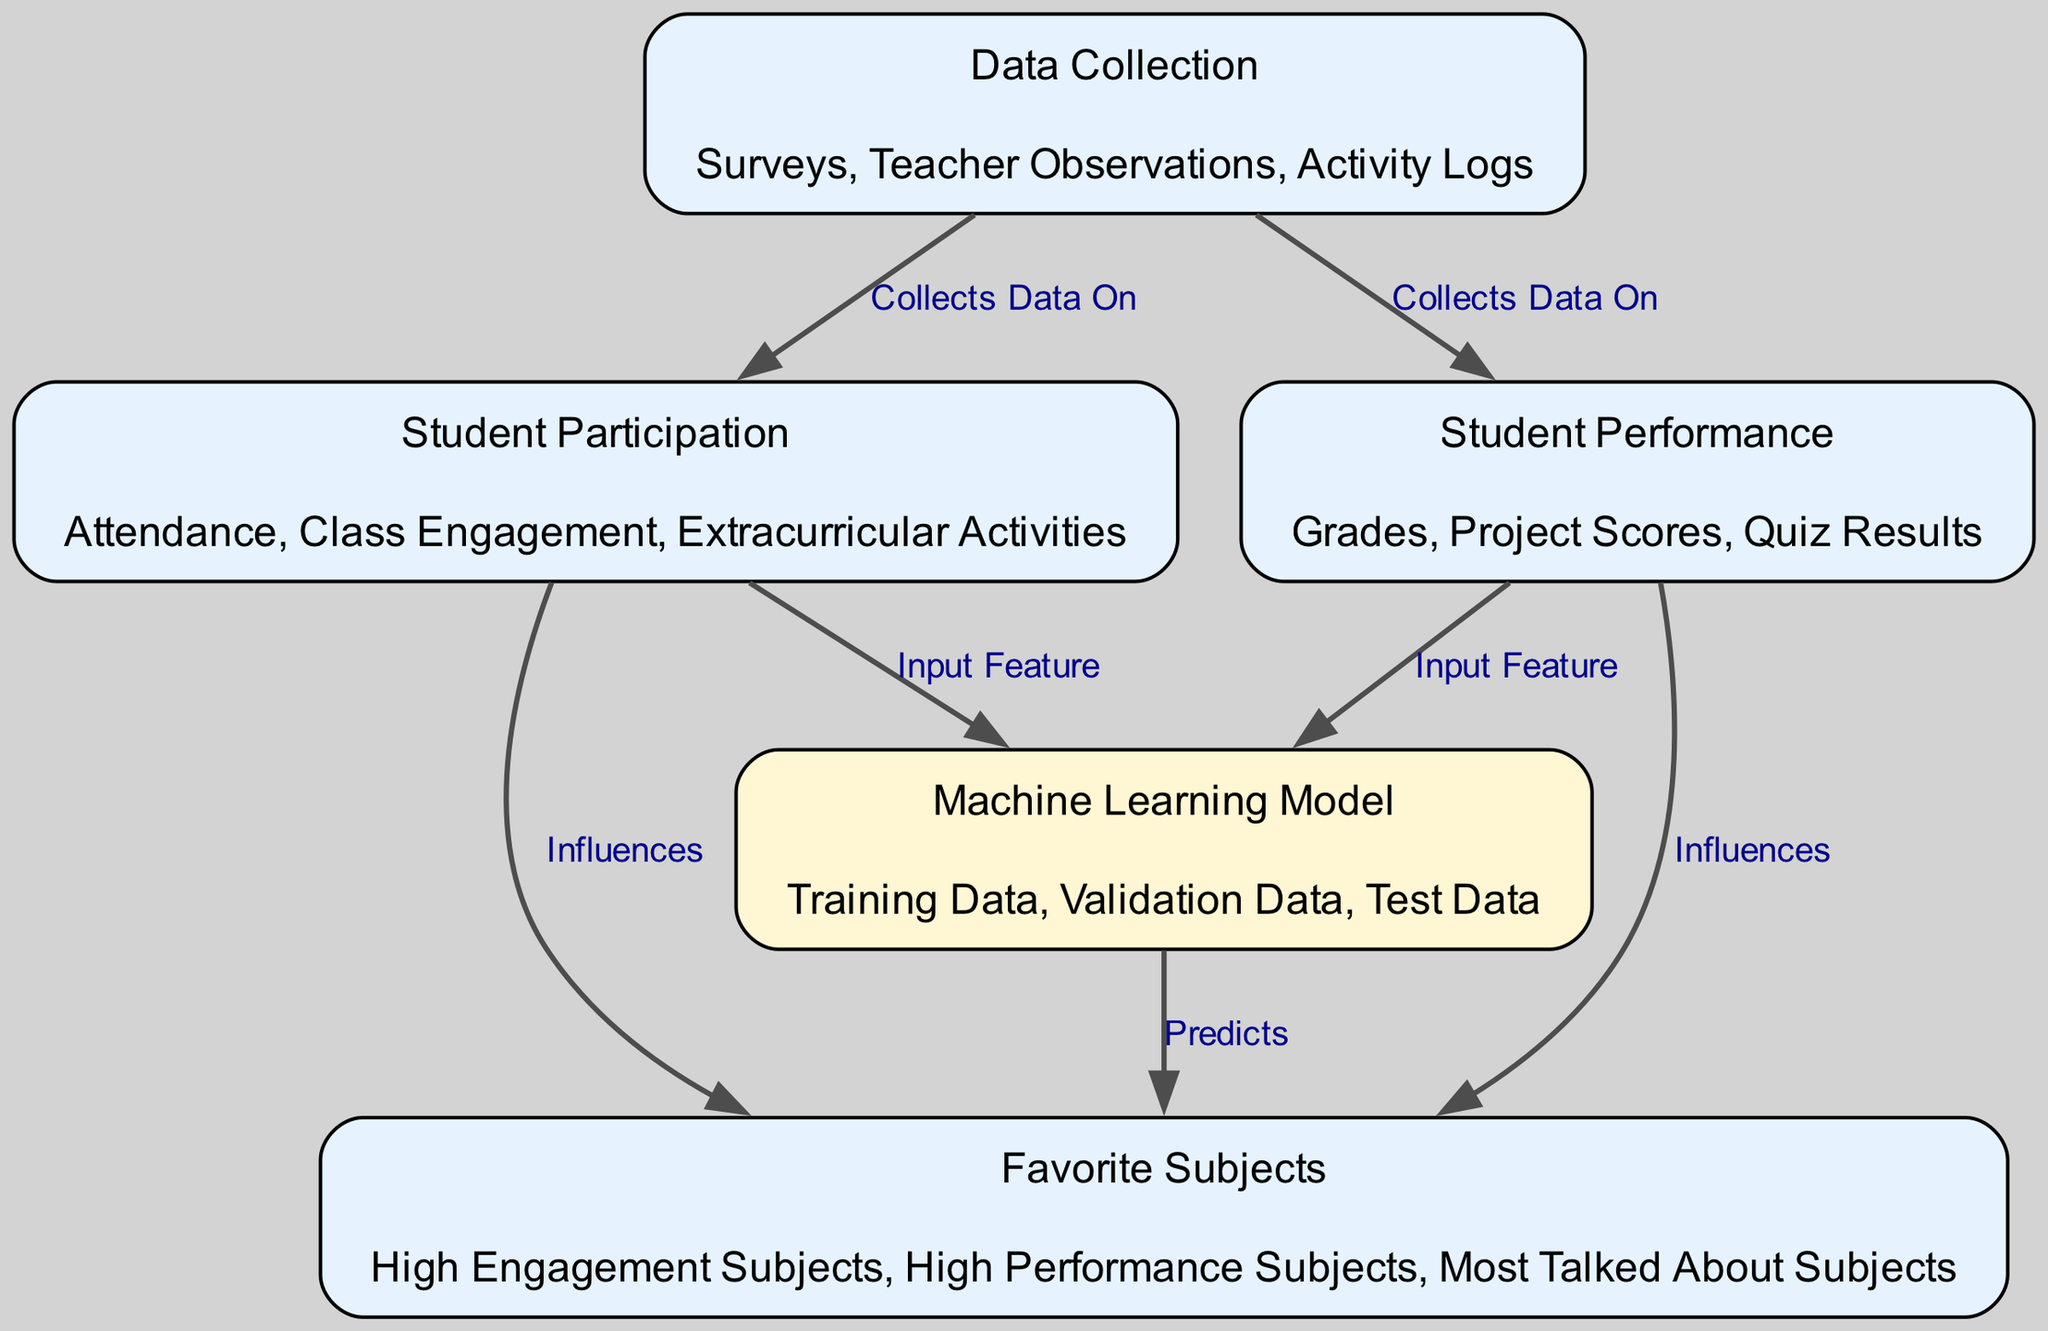What are the three attributes of Student Participation? The diagram lists "Attendance", "Class Engagement", and "Extracurricular Activities" as the attributes of the Student Participation node.
Answer: Attendance, Class Engagement, Extracurricular Activities How many edges are in the diagram? By counting the connections in the diagram, we find there are 8 edges connecting various nodes.
Answer: 8 Which node collects data on both Student Participation and Student Performance? The Data Collection node is connected to both Student Participation and Student Performance, indicating it collects data from these areas.
Answer: Data Collection What does the Machine Learning Model predict? The diagram shows that the Machine Learning Model outputs predictions related to Favorite Subjects, as indicated by the arrow pointing to it.
Answer: Favorite Subjects Which two nodes influence Favorite Subjects? The edges leading from Student Participation and Student Performance to Favorite Subjects indicate that both nodes influence it.
Answer: Student Participation, Student Performance What is the input feature to the Machine Learning Model from Student Participation? The diagram specifies that Student Participation acts as an input feature to the Machine Learning Model, as shown by the connecting edge.
Answer: Input Feature What kinds of data are mentioned in the Machine Learning Model attributes? The attributes of the Machine Learning Model include "Training Data", "Validation Data", and "Test Data". These are related to how the model is trained and tested.
Answer: Training Data, Validation Data, Test Data Which data collection methods are used? The diagram shows that surveys, teacher observations, and activity logs are the methods for data collection, listed under the Data Collection node.
Answer: Surveys, Teacher Observations, Activity Logs 